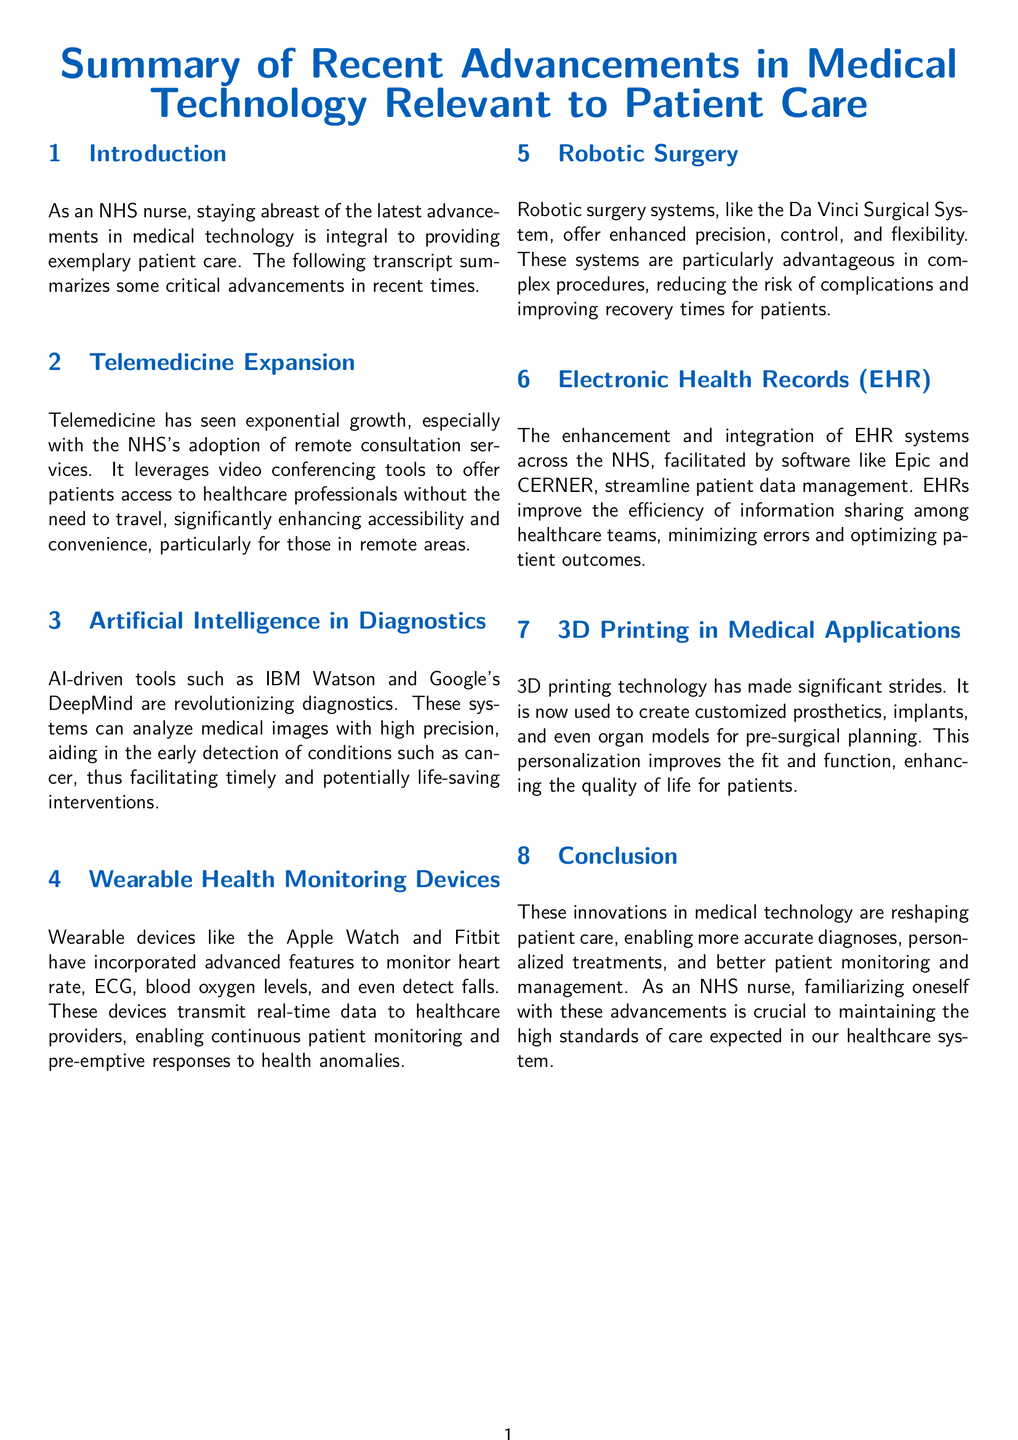What technology has seen exponential growth in the NHS? Telemedicine has experienced significant growth, particularly through the NHS's adoption of remote consultation services.
Answer: Telemedicine Which AI tools are mentioned for diagnostics? The document references IBM Watson and Google's DeepMind as AI-driven tools for diagnostics.
Answer: IBM Watson and Google's DeepMind What is one benefit of wearable health monitoring devices? Wearable devices transmit real-time data to healthcare providers, enabling continuous patient monitoring.
Answer: Continuous patient monitoring What system offers enhanced precision and flexibility in surgery? The Da Vinci Surgical System is highlighted for its enhanced precision, control, and flexibility in surgical procedures.
Answer: Da Vinci Surgical System What is the main purpose of Electronic Health Records (EHR)? EHRs streamline patient data management and improve the efficiency of information sharing among healthcare teams.
Answer: Streamline patient data management What medical application has been significantly improved by 3D printing? Customized prosthetics and implants are examples where 3D printing has made significant advancements.
Answer: Customized prosthetics and implants How does AI contribute to early detection of conditions like cancer? AI systems analyze medical images with high precision, aiding early detection of critical conditions.
Answer: Analyze medical images Why is it important for NHS nurses to keep up with technological advancements? Familiarizing with advancements is crucial to maintaining the high standards of care expected in the NHS healthcare system.
Answer: High standards of care 